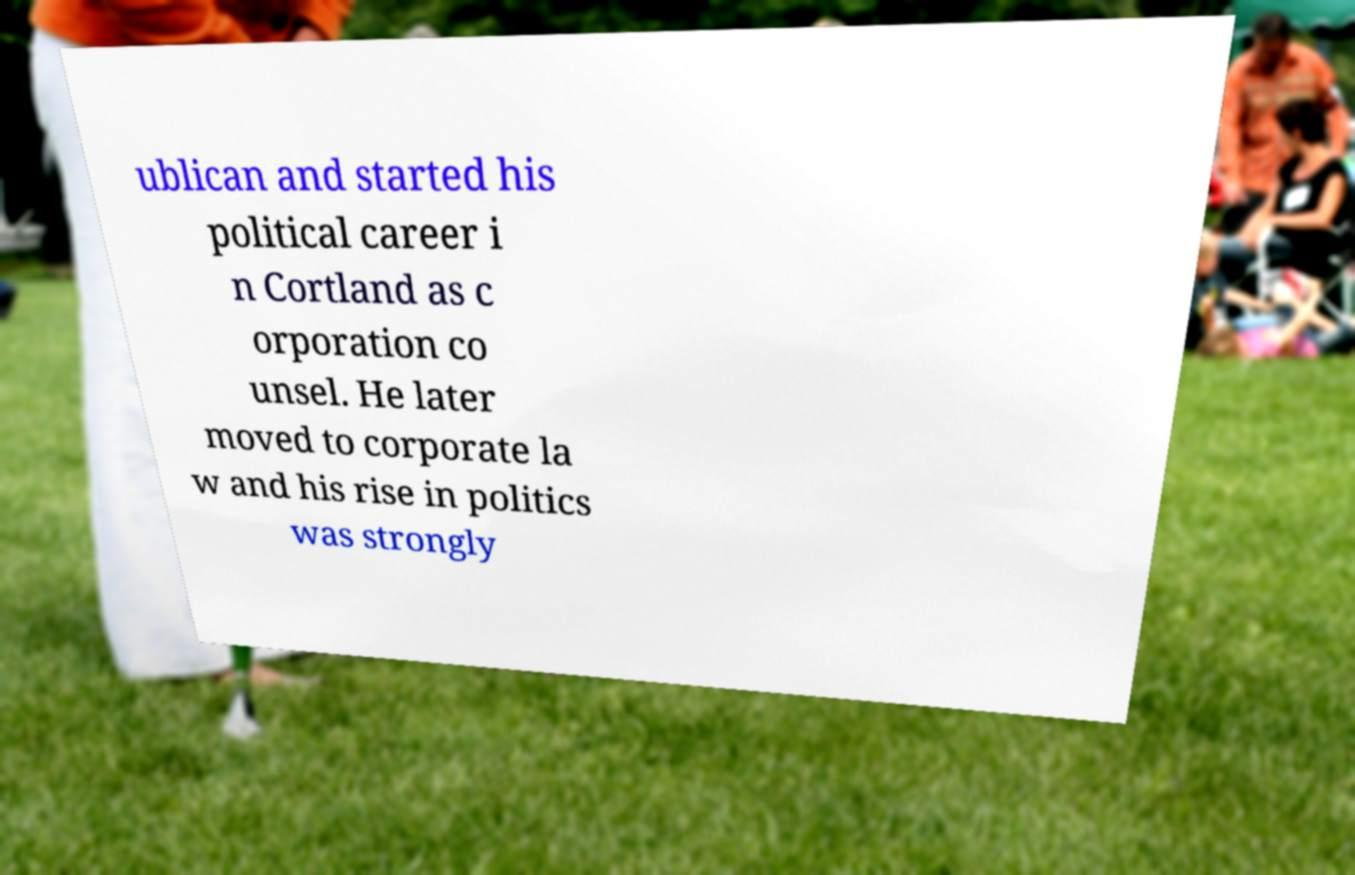What messages or text are displayed in this image? I need them in a readable, typed format. ublican and started his political career i n Cortland as c orporation co unsel. He later moved to corporate la w and his rise in politics was strongly 